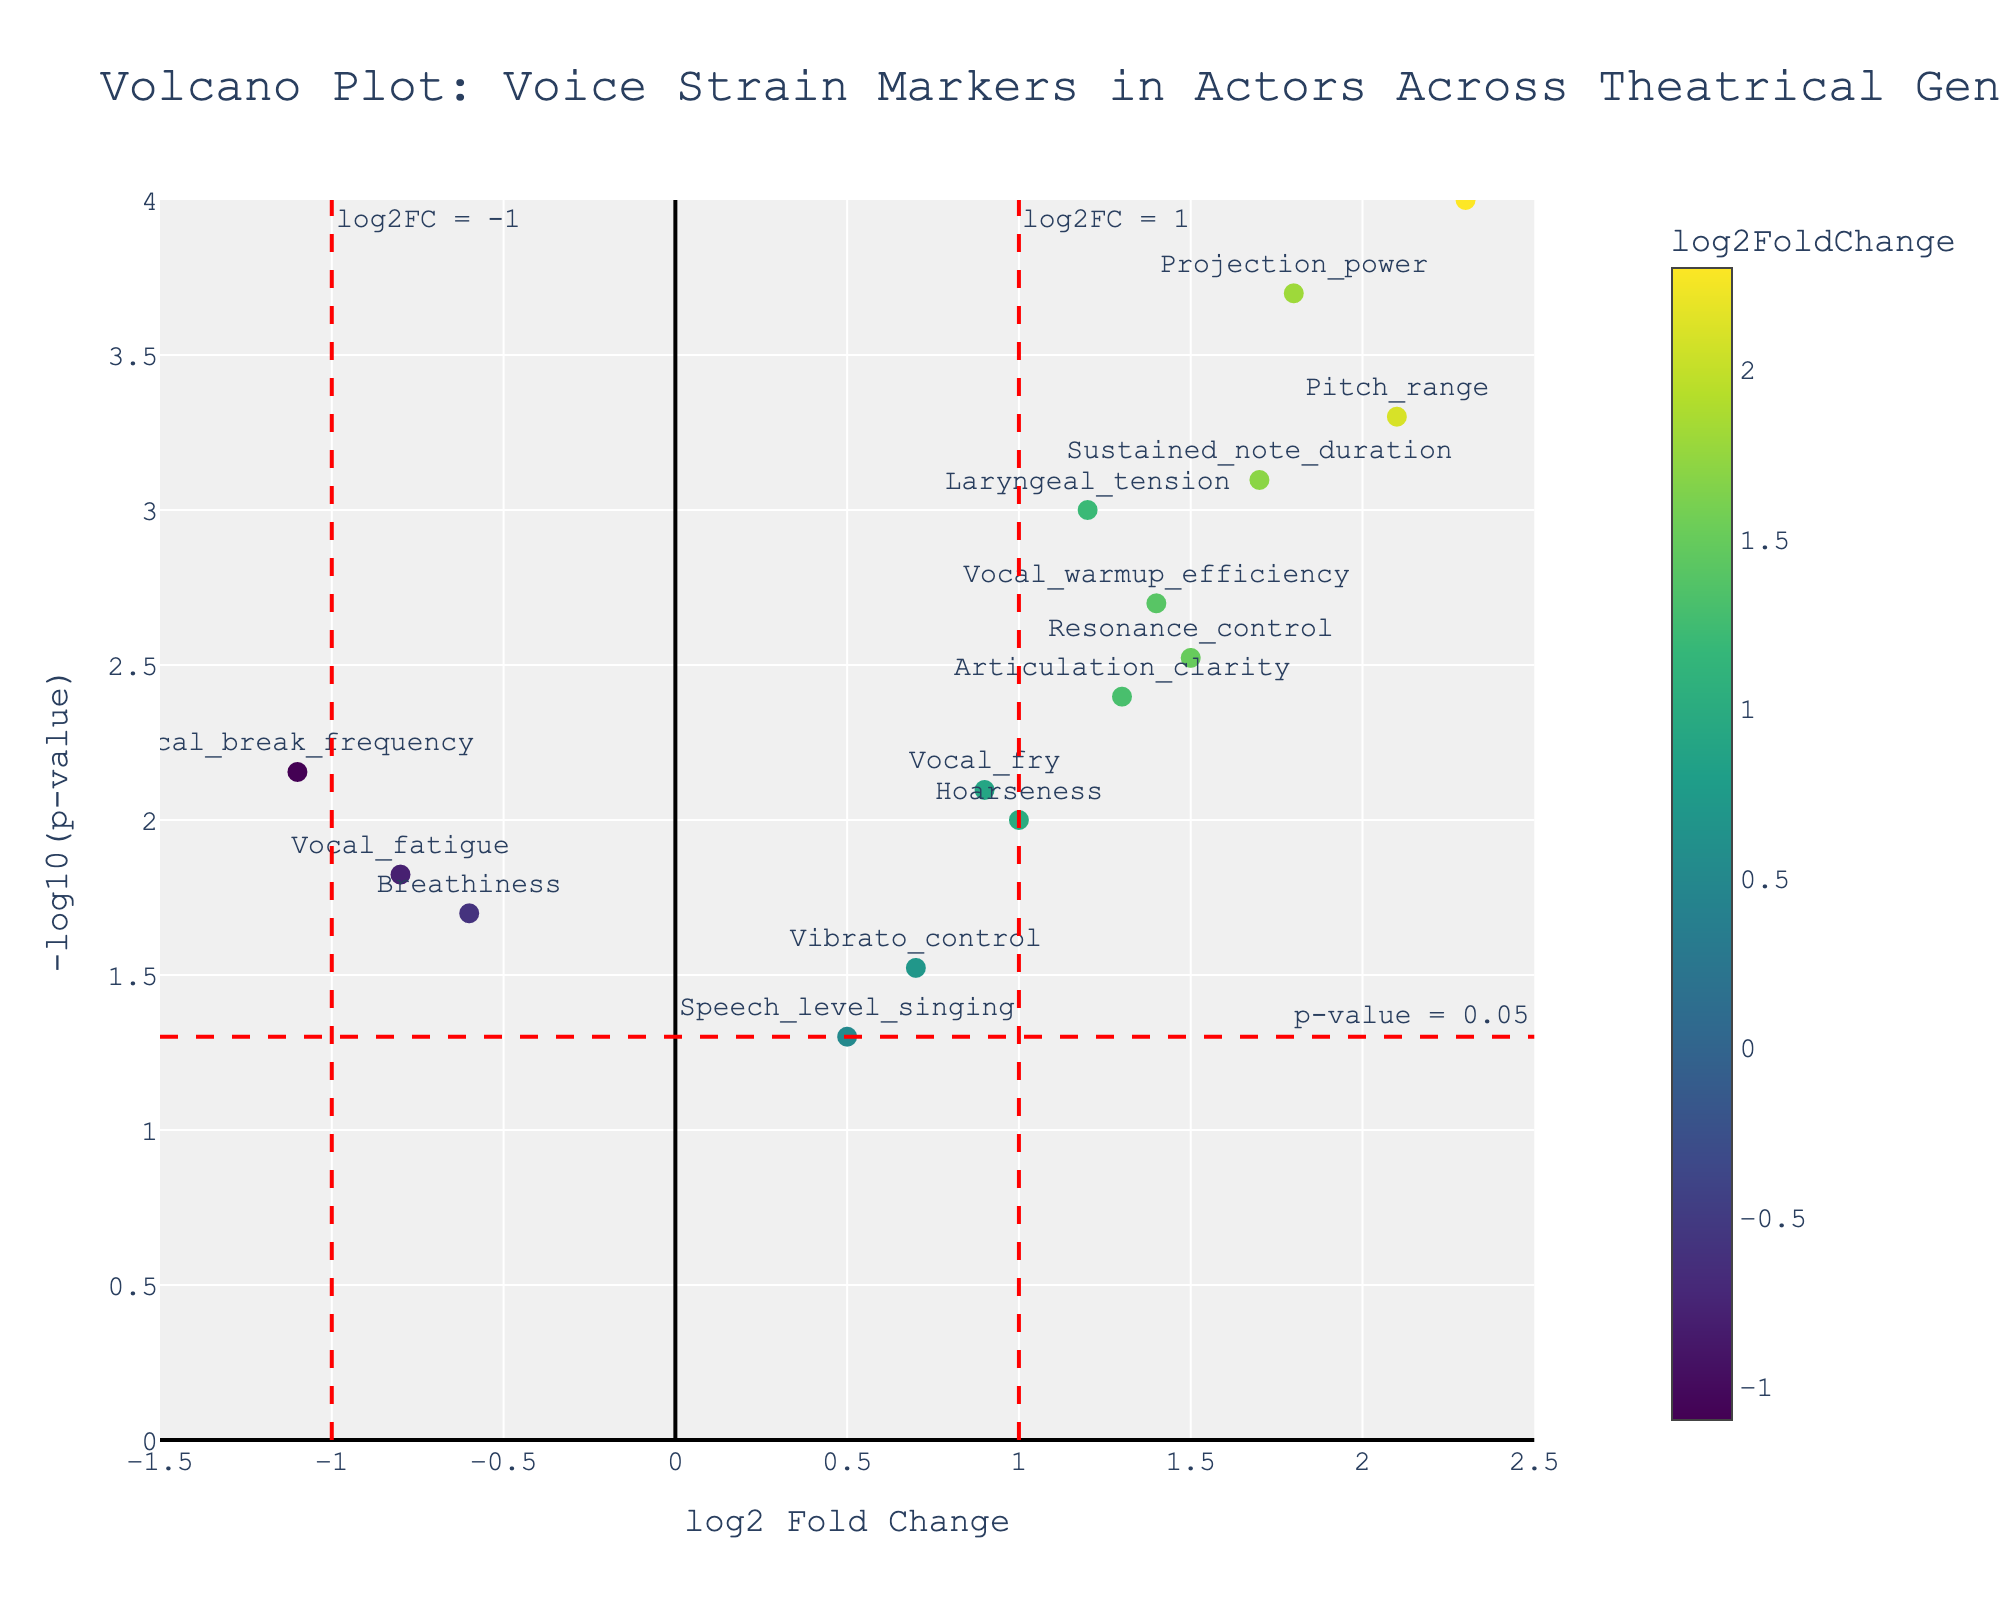What's the title of the plot? The title of the plot can often be found at the top of the figure and typically provides a summary of the figure content. Here, the title is located prominently at the top.
Answer: Volcano Plot: Voice Strain Markers in Actors Across Theatrical Genres How are the axes labeled in the plot? The x-axis and y-axis labels describe what each axis represents. In this figure, the x-axis is labeled "log2 Fold Change," and the y-axis is labeled "-log10(p-value)."
Answer: The x-axis is labeled "log2 Fold Change," and the y-axis is labeled "-log10(p-value)." Which gene has the highest log2 Fold Change? To find the gene with the highest log2 Fold Change, look for the data point farthest to the right on the x-axis. The corresponding label will reveal the gene.
Answer: Belting_technique How many genes have a log2 Fold Change greater than 1? Look for the vertical dashed line at log2 Fold Change = 1 and count all the genes to the right of it.
Answer: 7 genes What is the p-value threshold indicated on the plot, and how is it visualized? The p-value threshold is often marked by a horizontal line on a volcano plot. In this figure, it's shown by a red dashed line with an annotation text. The threshold line points to -log10(0.05) on the y-axis, which indicates the significance level.
Answer: The p-value threshold is 0.05, visualized by a red dashed line on the plot Which genes are considered significant based on the thresholds set in the plot? Genes to the left and right of the dotted vertical lines and above the horizontal line (p-value = 0.05) are considered significant. Look for which ones lie outside these boundaries and above the threshold line.
Answer: Belting_technique, Pitch_range, Projection_power, Sustained_note_duration, Laryngeal_tension, Resonance_control, Articulation_clarity, Hoarseness, Vocal_warmup_efficiency, Vocal_break_frequency How does the color scale relate to log2 Fold Change in the plot? The color scale in this plot represents the log2 Fold Change values, showing with color variations relative to these values. Each color corresponds to a specific log2 Fold Change, and the color bar provides a visual cue for interpretation.
Answer: The color scale represents log2 Fold Change values, correlating different shades to various log2 Fold Change magnitudes Which marker has a log2 Fold Change between 1 and 2 and a p-value less than 0.002? Filter out markers between log2 Fold Change of 1 and 2 and above -log10(p-value) of 2.7 on the plot. Look for the marker within these ranges and cross-reference with gene labels.
Answer: Articulation_clarity and Vocal_warmup_efficiency Arrange the genes with negative log2 Fold Change values according to their p-values. First, identify genes with negative log2 Fold Change values. Then order these genes by their p-values from smallest to largest, which can be done by looking at their vertical positions on the figure.
Answer: Vocal_break_frequency, Vocal_fatigue, Breathiness 